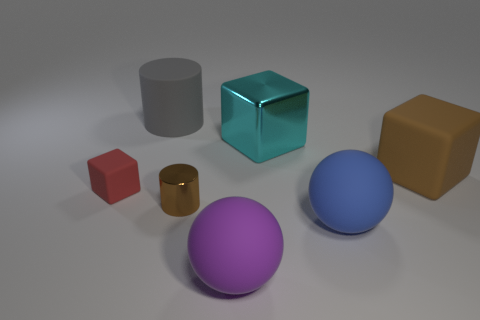Add 1 green matte cubes. How many objects exist? 8 Subtract all balls. How many objects are left? 5 Subtract all blue objects. Subtract all small brown shiny cylinders. How many objects are left? 5 Add 7 blocks. How many blocks are left? 10 Add 3 matte balls. How many matte balls exist? 5 Subtract 1 brown blocks. How many objects are left? 6 